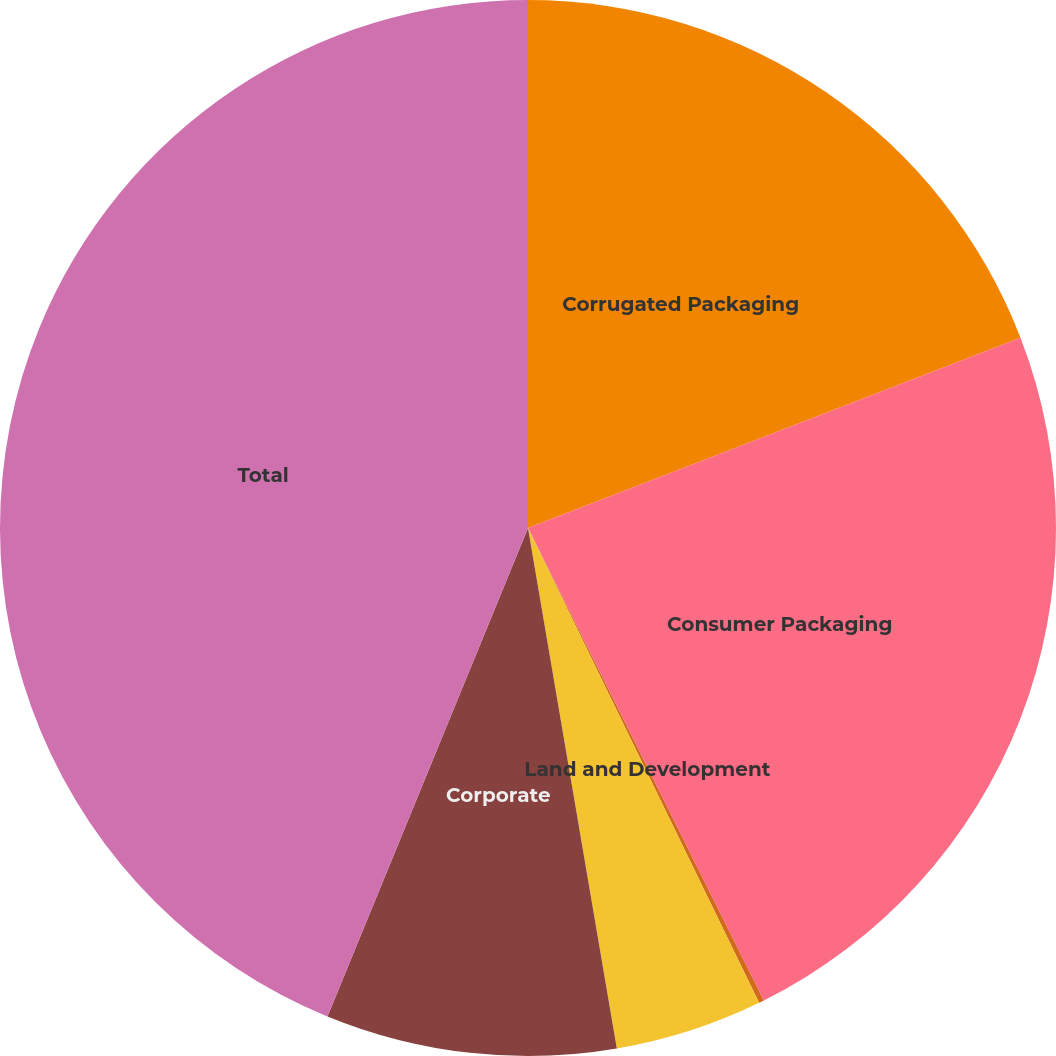Convert chart. <chart><loc_0><loc_0><loc_500><loc_500><pie_chart><fcel>Corrugated Packaging<fcel>Consumer Packaging<fcel>Land and Development<fcel>Assets held for sale<fcel>Corporate<fcel>Total<nl><fcel>19.13%<fcel>23.5%<fcel>0.16%<fcel>4.52%<fcel>8.89%<fcel>43.8%<nl></chart> 